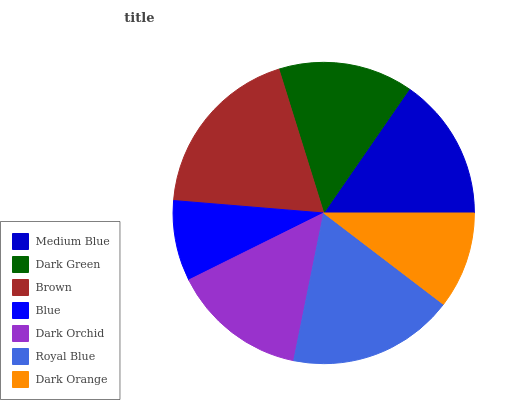Is Blue the minimum?
Answer yes or no. Yes. Is Brown the maximum?
Answer yes or no. Yes. Is Dark Green the minimum?
Answer yes or no. No. Is Dark Green the maximum?
Answer yes or no. No. Is Medium Blue greater than Dark Green?
Answer yes or no. Yes. Is Dark Green less than Medium Blue?
Answer yes or no. Yes. Is Dark Green greater than Medium Blue?
Answer yes or no. No. Is Medium Blue less than Dark Green?
Answer yes or no. No. Is Dark Orchid the high median?
Answer yes or no. Yes. Is Dark Orchid the low median?
Answer yes or no. Yes. Is Blue the high median?
Answer yes or no. No. Is Royal Blue the low median?
Answer yes or no. No. 